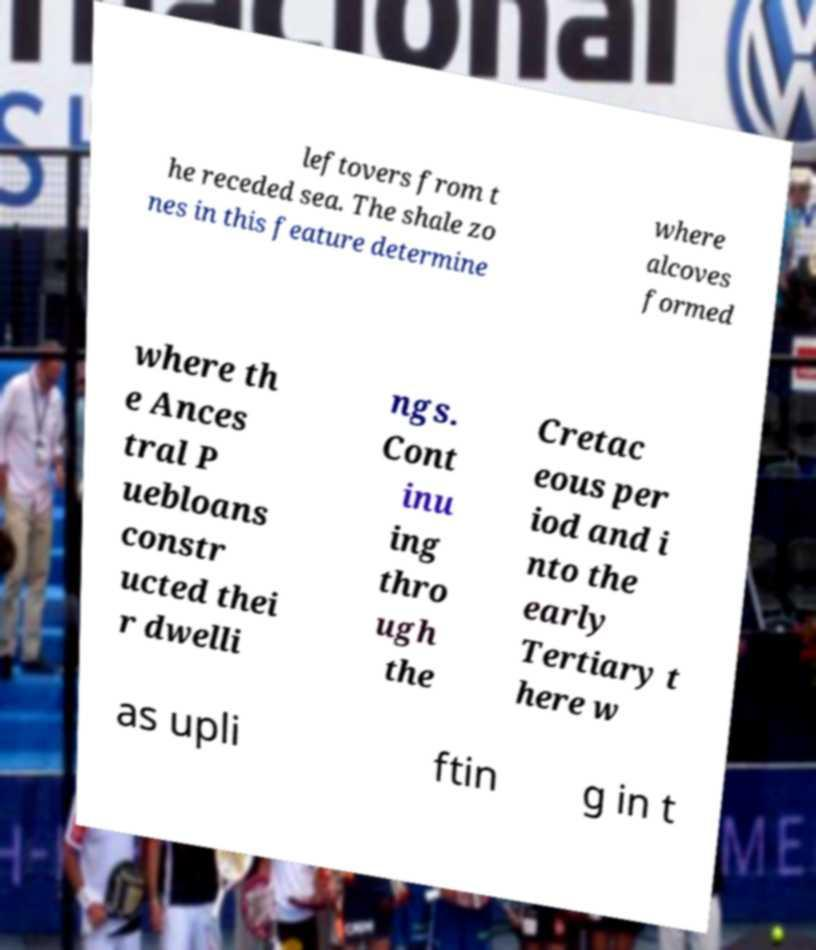Could you assist in decoding the text presented in this image and type it out clearly? leftovers from t he receded sea. The shale zo nes in this feature determine where alcoves formed where th e Ances tral P uebloans constr ucted thei r dwelli ngs. Cont inu ing thro ugh the Cretac eous per iod and i nto the early Tertiary t here w as upli ftin g in t 